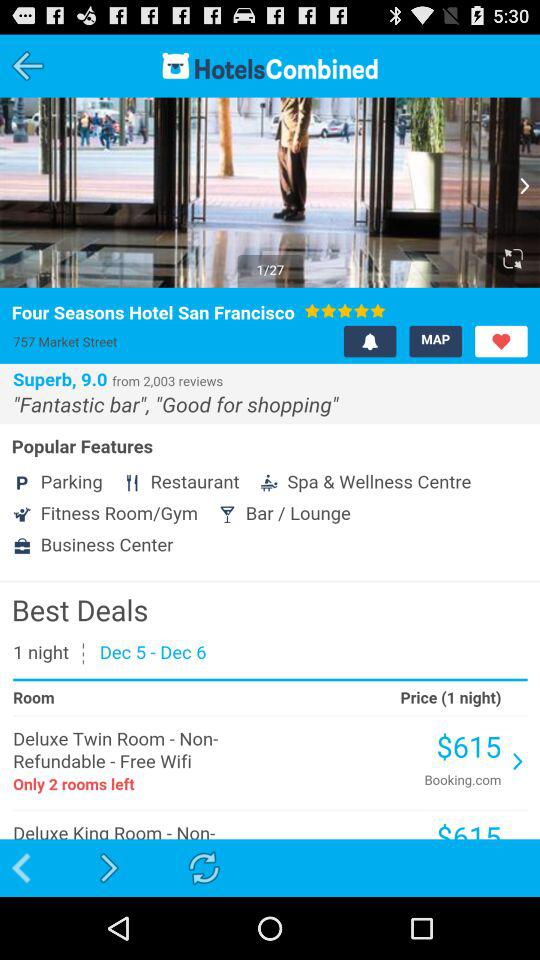What is the rating of the "Four Seasons Hotel San Francisco"? The rating is 5 stars. 